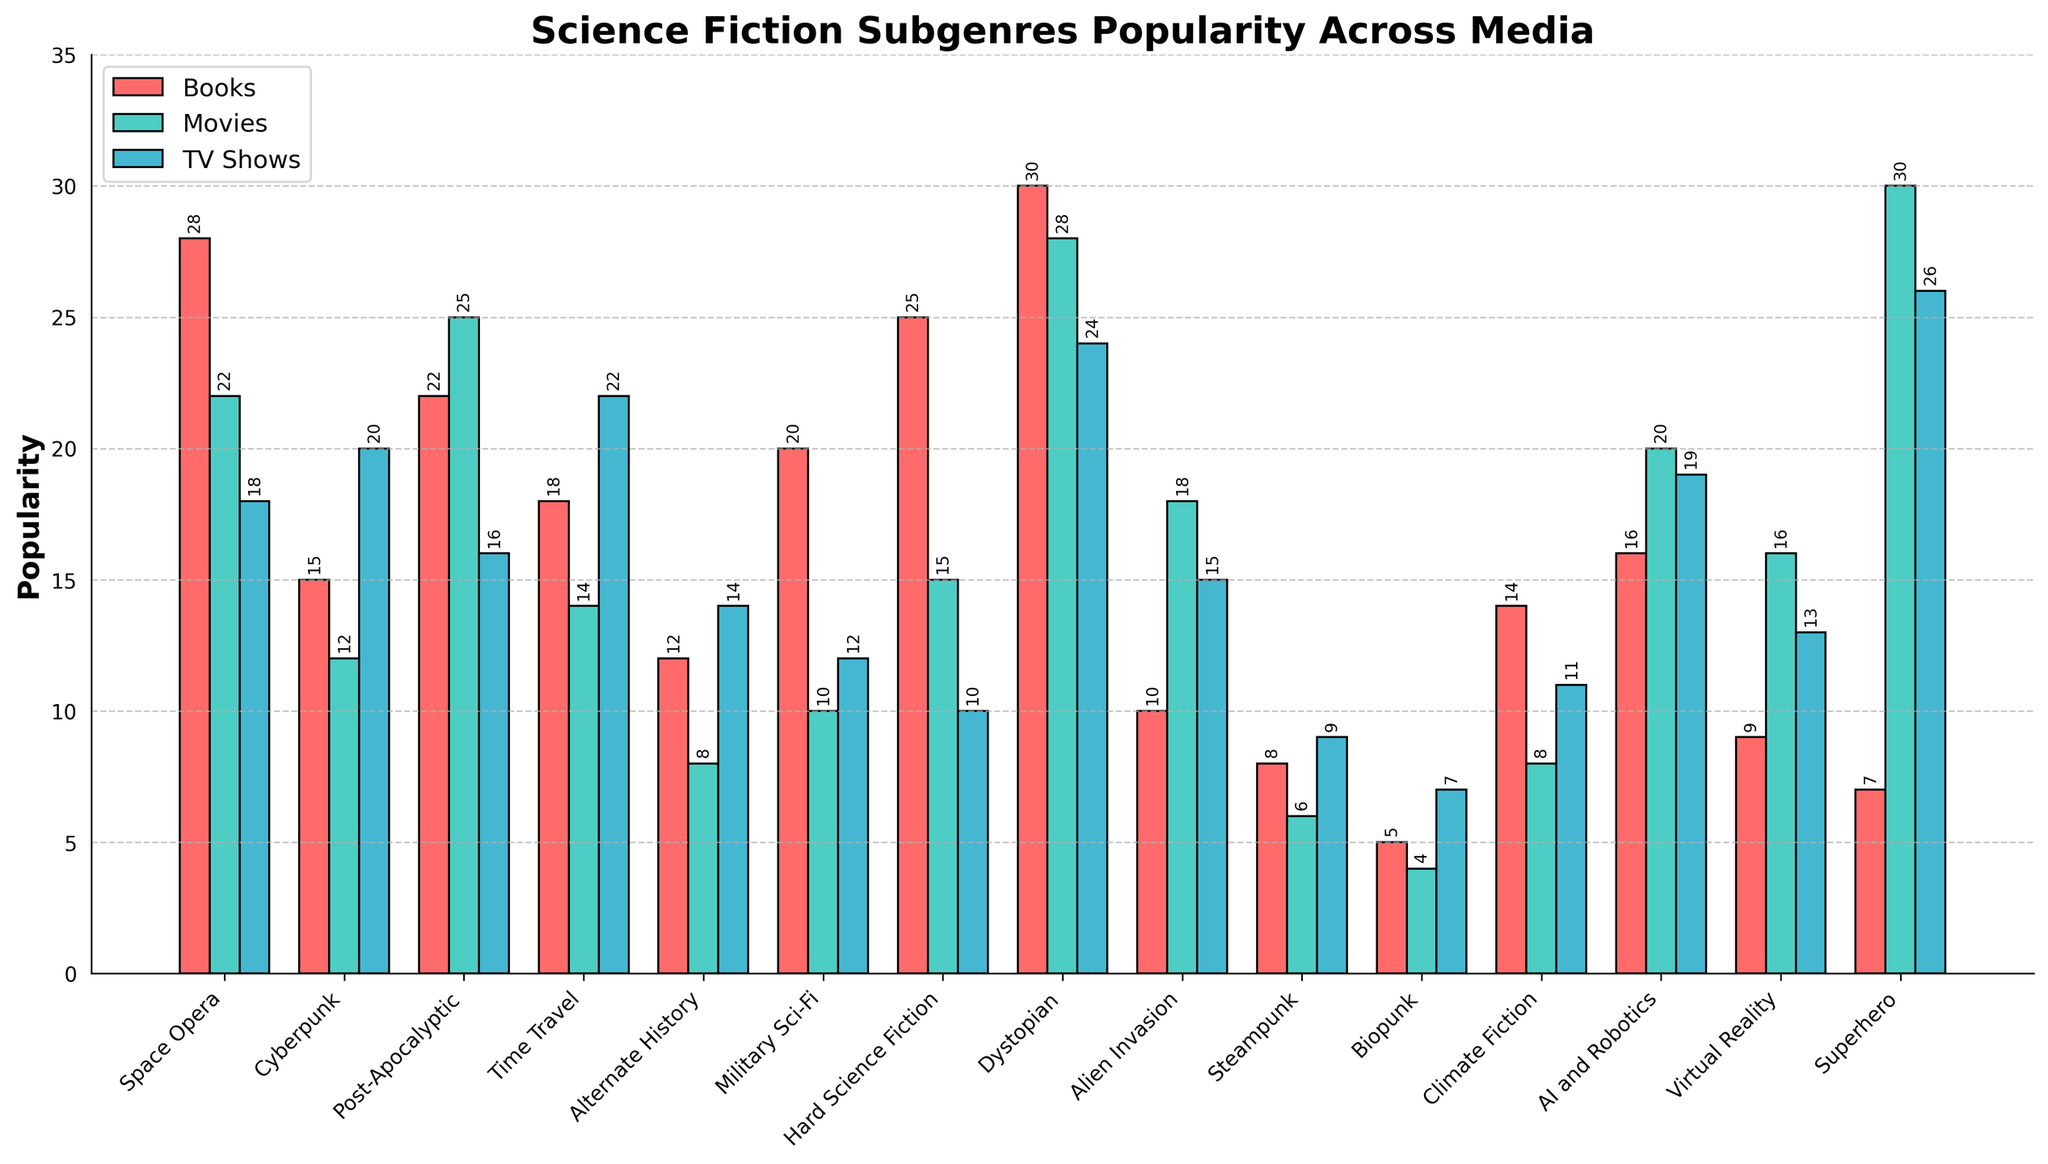Which subgenre is the most popular in books? By observing the bar heights, we can see that the 'Dystopian' subgenre has the highest bar in the 'Books' category, indicating the highest popularity.
Answer: Dystopian Which subgenre has the least popularity across all media formats combined? Summing up the values for each subgenre across Books, Movies, and TV Shows, we get that 'Biopunk' has the lowest total sum: 5 (Books) + 4 (Movies) + 7 (TV Shows) = 16.
Answer: Biopunk How does the popularity of 'Cyberpunk' in TV shows compare to 'Dystopian' in TV shows? By comparing the bar heights, we see that 'Cyberpunk' for TV shows is at 20 and 'Dystopian' is at 24, showing 'Dystopian' has higher popularity.
Answer: Dystopian > Cyberpunk Is 'Superhero' more popular in movies or TV shows? By comparing the bar heights, we can see that the bar for Movies is higher than that for TV Shows in the 'Superhero' subgenre: Movies (30) vs TV Shows (26).
Answer: Movies What is the approximate average popularity of 'Military Sci-Fi' across all three media formats? Adding the three values for 'Military Sci-Fi' (Books: 20, Movies: 10, TV Shows: 12) gives 42. Dividing by 3 gives the average: 42/3 = 14.
Answer: 14 Which medium generally has the highest popularity across all subgenres? Visually checking the aggregated height of bars across all subgenres for each medium, TV Shows and Movies are generally shorter than Books.
Answer: Books Do 'AI and Robotics' have equal popularity in TV Shows and Movies? Comparing the bar heights for 'AI and Robotics,' we find they are roughly equal in TV Shows (19) and Movies (20). The slight difference doesn't affect the overall interpretation.
Answer: Yes In which medium is 'Steampunk' least popular? The height of the bar for 'Steampunk' is lowest in Movies compared to Books and TV Shows.
Answer: Movies Which subgenre is most popular in TV Shows? By observing the bar heights, the 'Superhero' subgenre has the highest bar in the 'TV Shows' category, indicating the highest popularity.
Answer: Superhero 